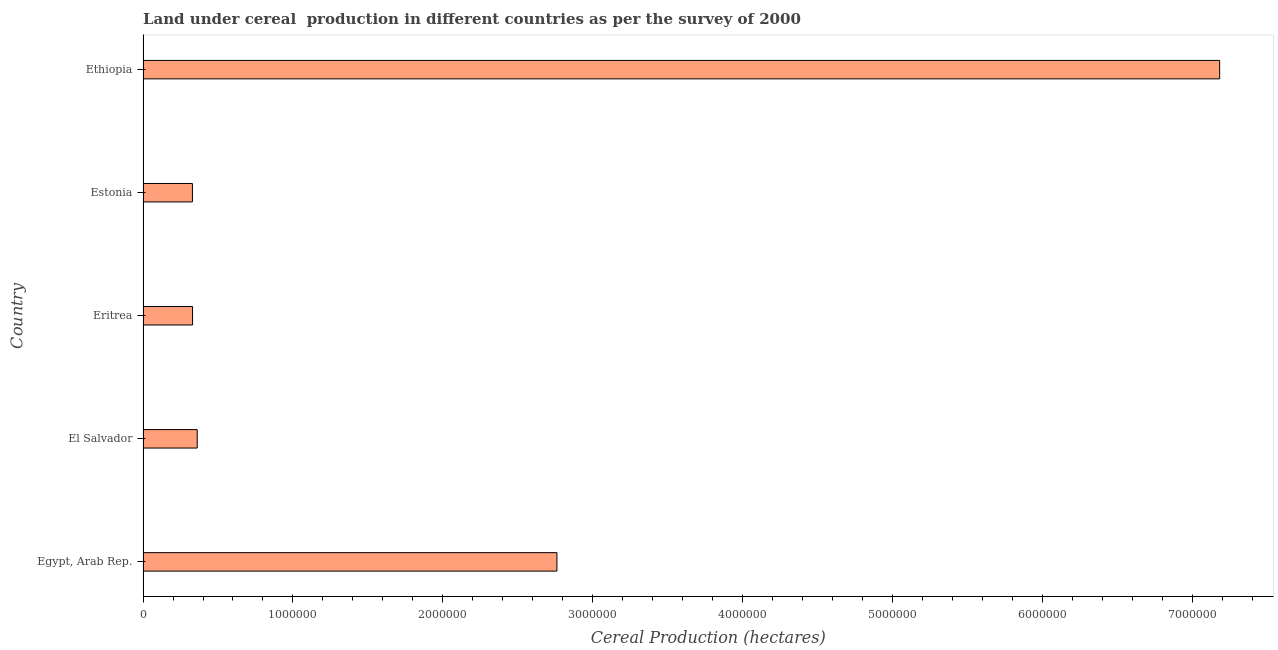Does the graph contain grids?
Your response must be concise. No. What is the title of the graph?
Offer a terse response. Land under cereal  production in different countries as per the survey of 2000. What is the label or title of the X-axis?
Your answer should be very brief. Cereal Production (hectares). What is the land under cereal production in Ethiopia?
Offer a very short reply. 7.18e+06. Across all countries, what is the maximum land under cereal production?
Keep it short and to the point. 7.18e+06. Across all countries, what is the minimum land under cereal production?
Keep it short and to the point. 3.29e+05. In which country was the land under cereal production maximum?
Keep it short and to the point. Ethiopia. In which country was the land under cereal production minimum?
Provide a short and direct response. Estonia. What is the sum of the land under cereal production?
Your answer should be compact. 1.10e+07. What is the difference between the land under cereal production in Egypt, Arab Rep. and Estonia?
Provide a succinct answer. 2.43e+06. What is the average land under cereal production per country?
Make the answer very short. 2.19e+06. What is the median land under cereal production?
Provide a succinct answer. 3.61e+05. What is the ratio of the land under cereal production in Estonia to that in Ethiopia?
Your answer should be very brief. 0.05. Is the land under cereal production in Eritrea less than that in Estonia?
Ensure brevity in your answer.  No. What is the difference between the highest and the second highest land under cereal production?
Make the answer very short. 4.42e+06. What is the difference between the highest and the lowest land under cereal production?
Your answer should be compact. 6.85e+06. In how many countries, is the land under cereal production greater than the average land under cereal production taken over all countries?
Your answer should be very brief. 2. What is the difference between two consecutive major ticks on the X-axis?
Your response must be concise. 1.00e+06. Are the values on the major ticks of X-axis written in scientific E-notation?
Ensure brevity in your answer.  No. What is the Cereal Production (hectares) of Egypt, Arab Rep.?
Offer a terse response. 2.76e+06. What is the Cereal Production (hectares) of El Salvador?
Offer a terse response. 3.61e+05. What is the Cereal Production (hectares) in Eritrea?
Ensure brevity in your answer.  3.30e+05. What is the Cereal Production (hectares) in Estonia?
Your answer should be compact. 3.29e+05. What is the Cereal Production (hectares) of Ethiopia?
Keep it short and to the point. 7.18e+06. What is the difference between the Cereal Production (hectares) in Egypt, Arab Rep. and El Salvador?
Ensure brevity in your answer.  2.40e+06. What is the difference between the Cereal Production (hectares) in Egypt, Arab Rep. and Eritrea?
Ensure brevity in your answer.  2.43e+06. What is the difference between the Cereal Production (hectares) in Egypt, Arab Rep. and Estonia?
Your answer should be very brief. 2.43e+06. What is the difference between the Cereal Production (hectares) in Egypt, Arab Rep. and Ethiopia?
Provide a succinct answer. -4.42e+06. What is the difference between the Cereal Production (hectares) in El Salvador and Eritrea?
Keep it short and to the point. 3.12e+04. What is the difference between the Cereal Production (hectares) in El Salvador and Estonia?
Provide a short and direct response. 3.19e+04. What is the difference between the Cereal Production (hectares) in El Salvador and Ethiopia?
Your answer should be very brief. -6.82e+06. What is the difference between the Cereal Production (hectares) in Eritrea and Estonia?
Ensure brevity in your answer.  752. What is the difference between the Cereal Production (hectares) in Eritrea and Ethiopia?
Your answer should be very brief. -6.85e+06. What is the difference between the Cereal Production (hectares) in Estonia and Ethiopia?
Give a very brief answer. -6.85e+06. What is the ratio of the Cereal Production (hectares) in Egypt, Arab Rep. to that in El Salvador?
Make the answer very short. 7.64. What is the ratio of the Cereal Production (hectares) in Egypt, Arab Rep. to that in Eritrea?
Offer a very short reply. 8.36. What is the ratio of the Cereal Production (hectares) in Egypt, Arab Rep. to that in Estonia?
Your answer should be compact. 8.38. What is the ratio of the Cereal Production (hectares) in Egypt, Arab Rep. to that in Ethiopia?
Give a very brief answer. 0.38. What is the ratio of the Cereal Production (hectares) in El Salvador to that in Eritrea?
Your answer should be compact. 1.09. What is the ratio of the Cereal Production (hectares) in El Salvador to that in Estonia?
Make the answer very short. 1.1. What is the ratio of the Cereal Production (hectares) in Eritrea to that in Ethiopia?
Ensure brevity in your answer.  0.05. What is the ratio of the Cereal Production (hectares) in Estonia to that in Ethiopia?
Your answer should be compact. 0.05. 